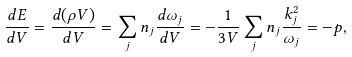Convert formula to latex. <formula><loc_0><loc_0><loc_500><loc_500>\frac { d E } { d V } = \frac { d ( \rho V ) } { d V } = \sum _ { j } n _ { j } \frac { d \omega _ { j } } { d V } = - \frac { 1 } { 3 V } \sum _ { j } n _ { j } \frac { k _ { j } ^ { 2 } } { \omega _ { j } } = - p ,</formula> 